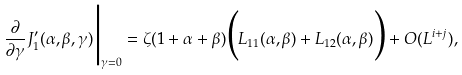<formula> <loc_0><loc_0><loc_500><loc_500>\frac { \partial } { \partial \gamma } J _ { 1 } ^ { \prime } ( \alpha , \beta , \gamma ) \Big | _ { \gamma = 0 } = \zeta ( 1 + \alpha + \beta ) \Big ( L _ { 1 1 } ( \alpha , \beta ) + L _ { 1 2 } ( \alpha , \beta ) \Big ) + O ( L ^ { i + j } ) ,</formula> 